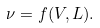<formula> <loc_0><loc_0><loc_500><loc_500>\nu = f ( V , L ) .</formula> 